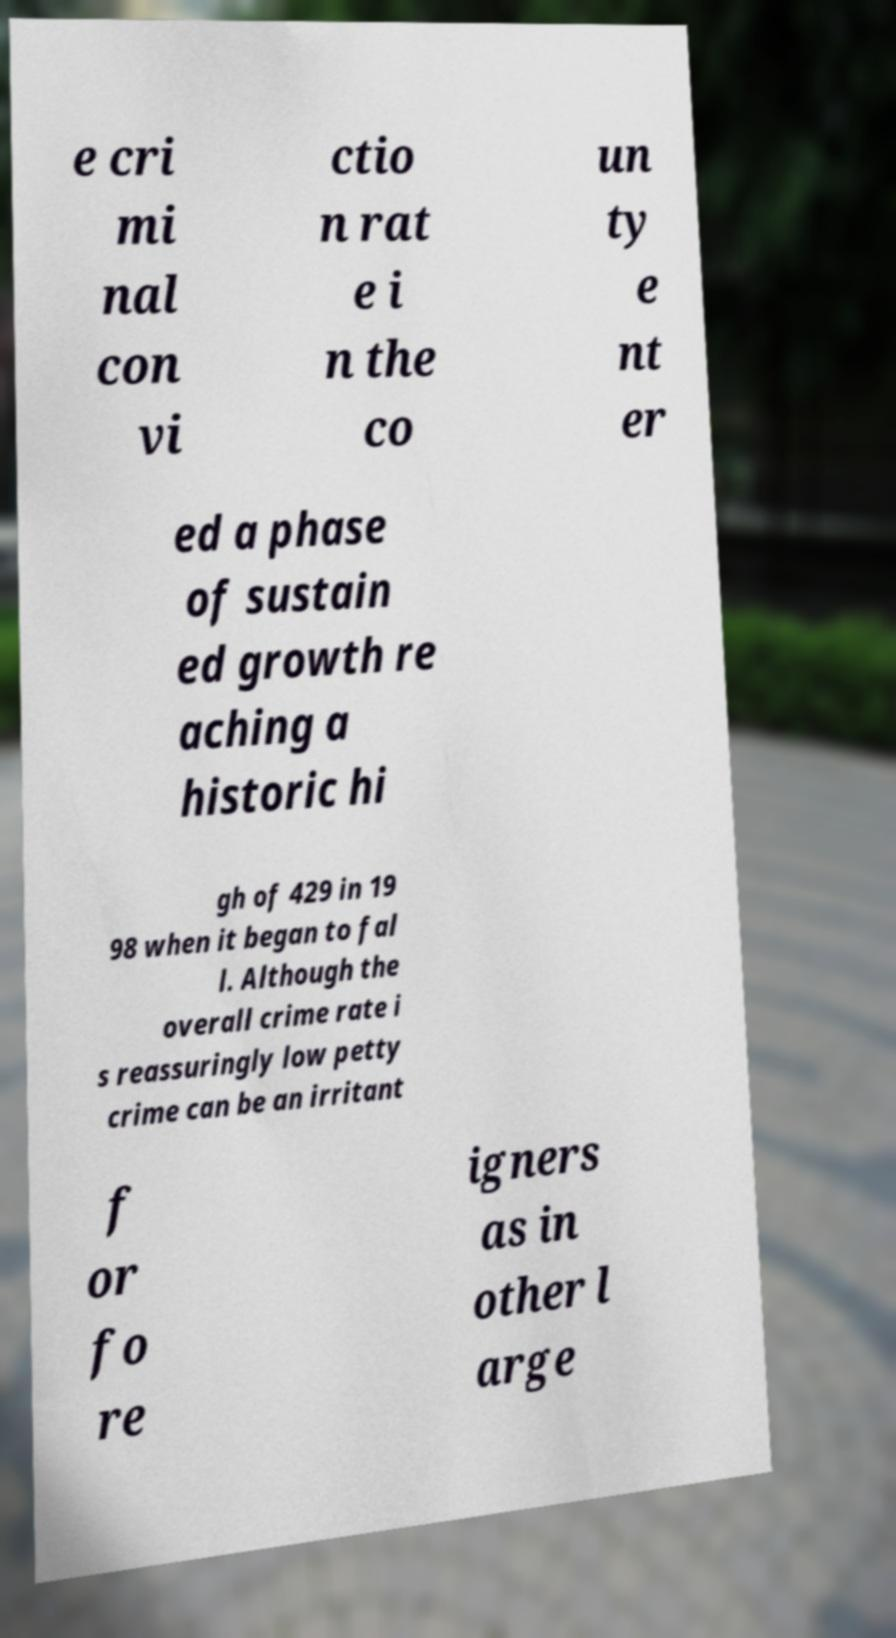Can you accurately transcribe the text from the provided image for me? e cri mi nal con vi ctio n rat e i n the co un ty e nt er ed a phase of sustain ed growth re aching a historic hi gh of 429 in 19 98 when it began to fal l. Although the overall crime rate i s reassuringly low petty crime can be an irritant f or fo re igners as in other l arge 